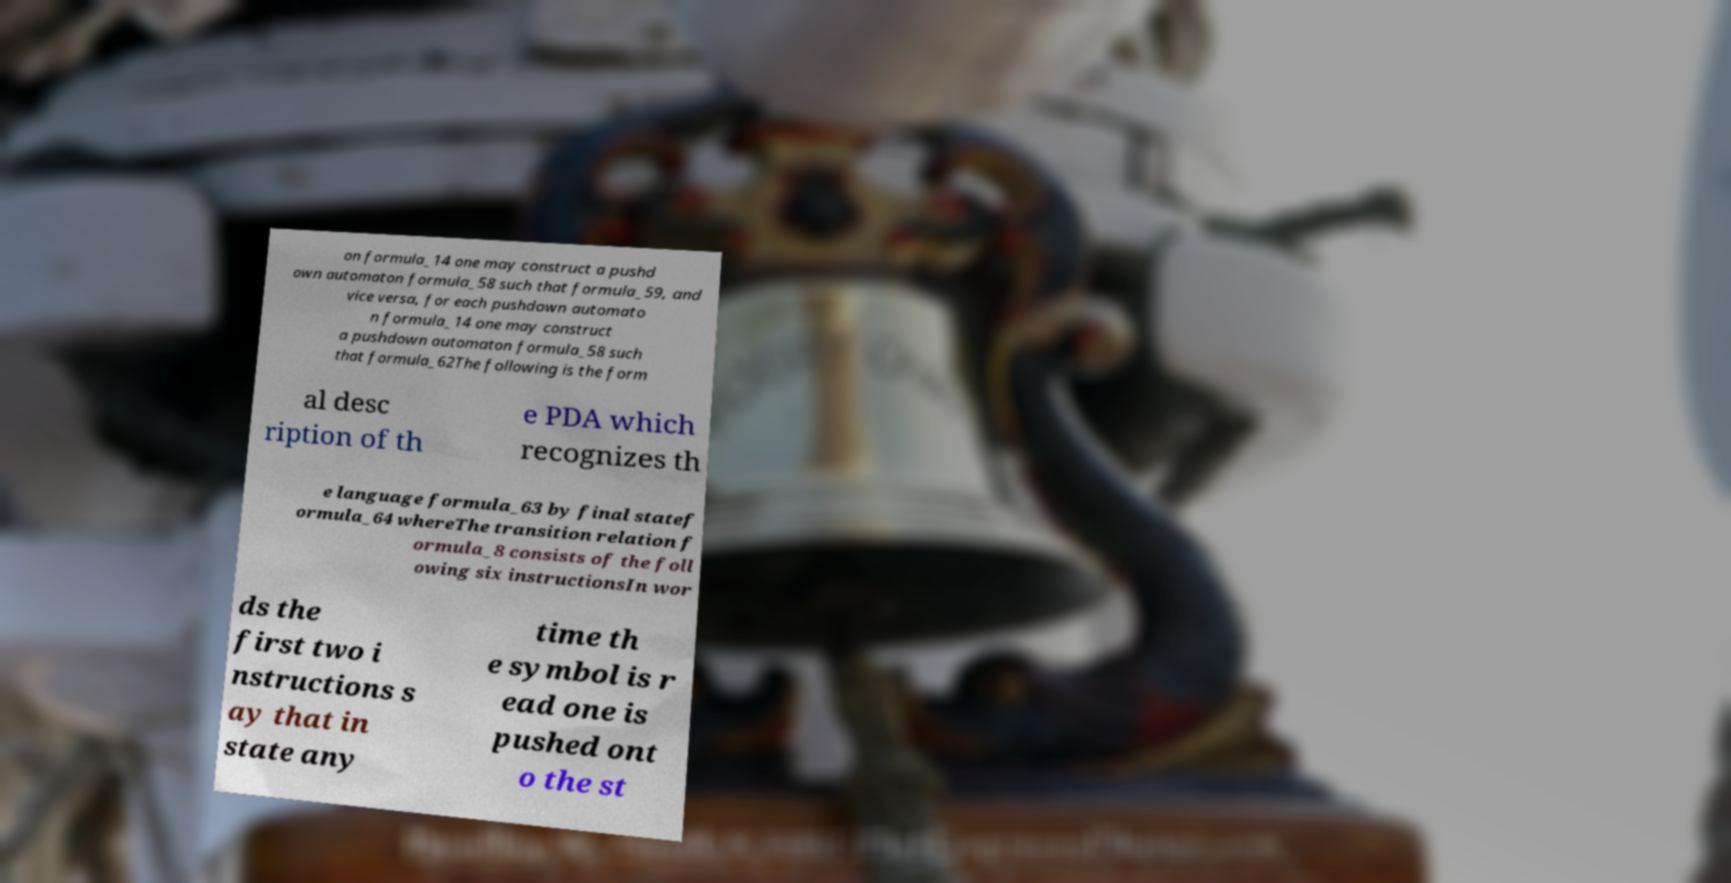For documentation purposes, I need the text within this image transcribed. Could you provide that? on formula_14 one may construct a pushd own automaton formula_58 such that formula_59, and vice versa, for each pushdown automato n formula_14 one may construct a pushdown automaton formula_58 such that formula_62The following is the form al desc ription of th e PDA which recognizes th e language formula_63 by final statef ormula_64 whereThe transition relation f ormula_8 consists of the foll owing six instructionsIn wor ds the first two i nstructions s ay that in state any time th e symbol is r ead one is pushed ont o the st 